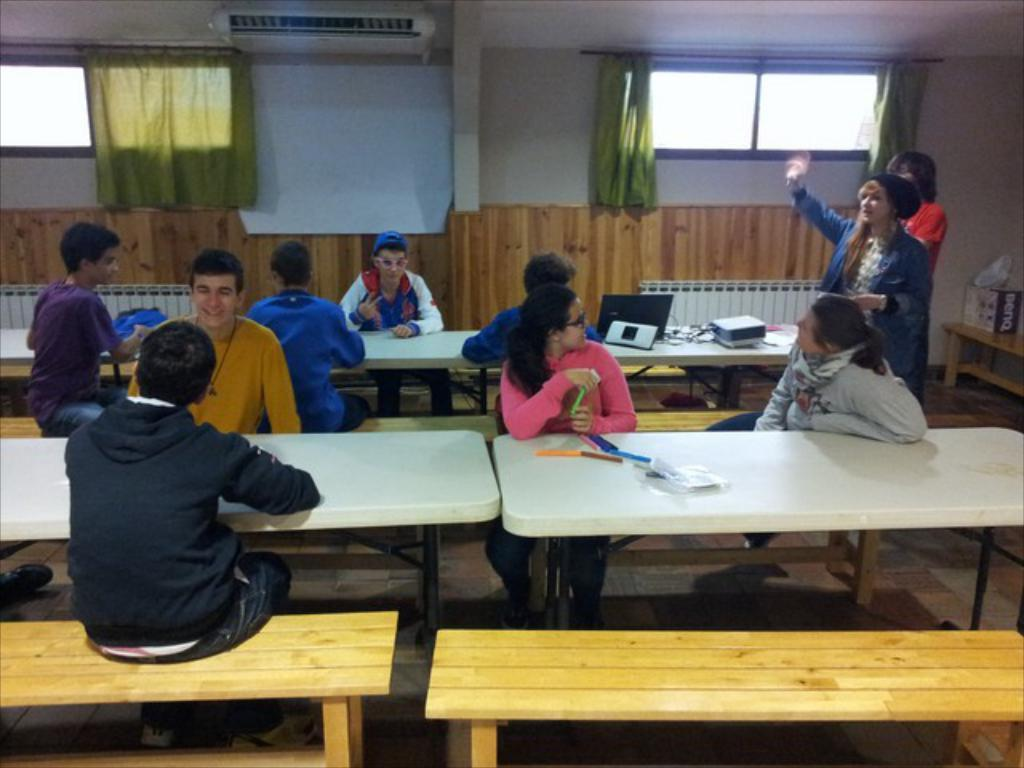What are the people in the image doing? There is a group of persons sitting on a bench in the image. What object is in front of the group of persons? There is a white table in front of the group of persons. Are there any other people visible in the image? Yes, two persons are standing in the right corner of the image. What invention is being demonstrated by the group of persons in the image? There is no invention being demonstrated in the image; the group of persons is simply sitting on a bench. Can you see any balloons in the image? No, there are no balloons present in the image. 